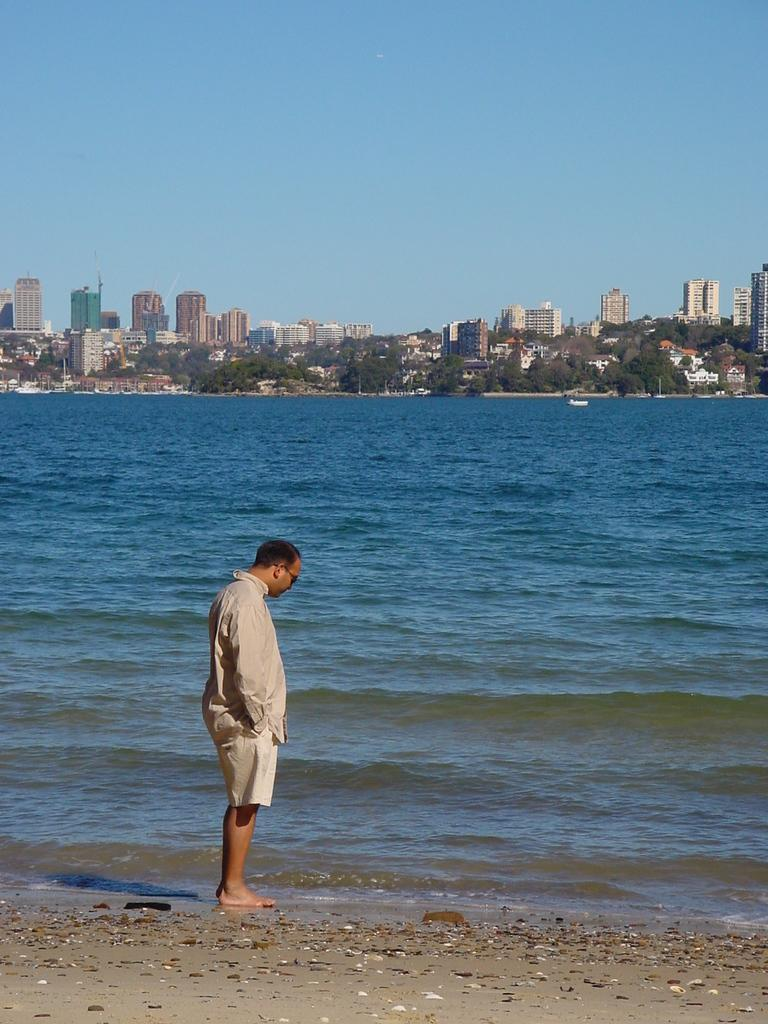What is the person in the image doing? The person is standing on the seashore. What can be seen in the background of the image? There is water, trees, buildings, poles, and the sky visible in the background. Can you describe the natural elements in the image? The natural elements include the seashore, water, and trees. What type of degree does the person in the image have? There is no information about the person's degree in the image. Can you see any dinosaurs in the image? No, there are no dinosaurs present in the image. 